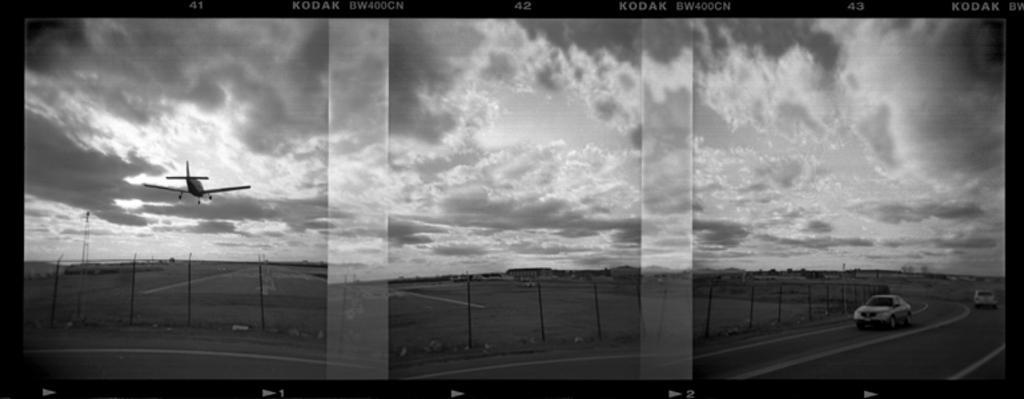<image>
Relay a brief, clear account of the picture shown. A real of Kodak film shows a plane in the air. 